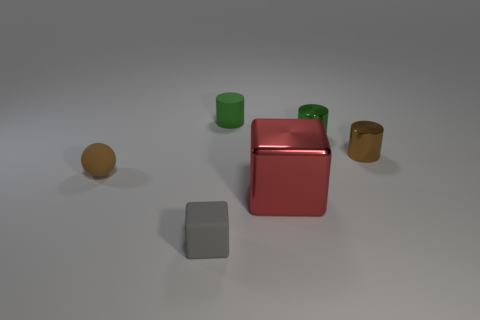Subtract all balls. How many objects are left? 5 Add 2 purple matte blocks. How many objects exist? 8 Subtract all small blue spheres. Subtract all brown metal cylinders. How many objects are left? 5 Add 5 tiny brown cylinders. How many tiny brown cylinders are left? 6 Add 5 tiny brown shiny cylinders. How many tiny brown shiny cylinders exist? 6 Subtract 0 green cubes. How many objects are left? 6 